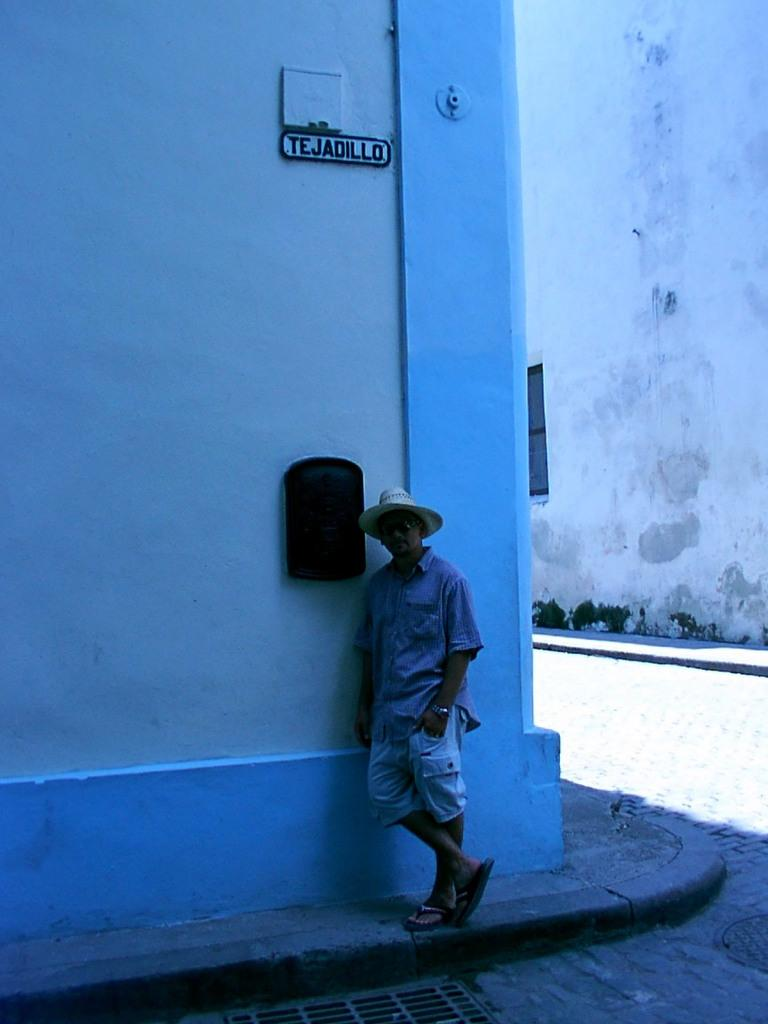What is the main subject in the front of the image? There is a person standing in the front of the image. What can be seen in the background of the image? There are walls in the background of the image. Is there any text visible in the image? Yes, there is some text written on the wall. What type of wood is used to make the cream in the image? There is no cream or wood present in the image. How many rings can be seen on the person's finger in the image? There is no person wearing a ring in the image. 